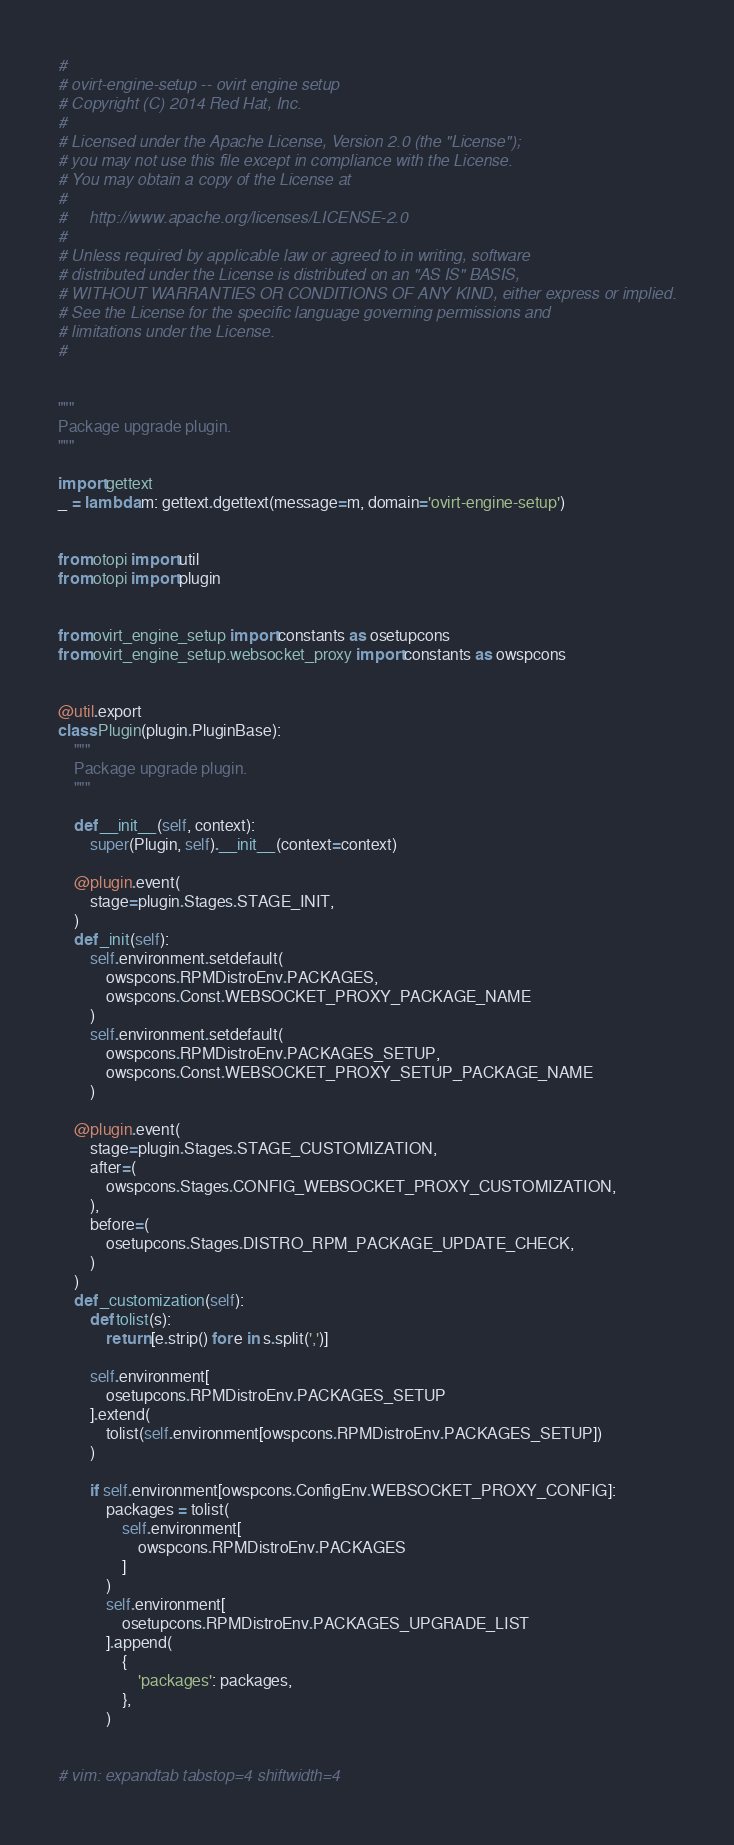Convert code to text. <code><loc_0><loc_0><loc_500><loc_500><_Python_>#
# ovirt-engine-setup -- ovirt engine setup
# Copyright (C) 2014 Red Hat, Inc.
#
# Licensed under the Apache License, Version 2.0 (the "License");
# you may not use this file except in compliance with the License.
# You may obtain a copy of the License at
#
#     http://www.apache.org/licenses/LICENSE-2.0
#
# Unless required by applicable law or agreed to in writing, software
# distributed under the License is distributed on an "AS IS" BASIS,
# WITHOUT WARRANTIES OR CONDITIONS OF ANY KIND, either express or implied.
# See the License for the specific language governing permissions and
# limitations under the License.
#


"""
Package upgrade plugin.
"""

import gettext
_ = lambda m: gettext.dgettext(message=m, domain='ovirt-engine-setup')


from otopi import util
from otopi import plugin


from ovirt_engine_setup import constants as osetupcons
from ovirt_engine_setup.websocket_proxy import constants as owspcons


@util.export
class Plugin(plugin.PluginBase):
    """
    Package upgrade plugin.
    """

    def __init__(self, context):
        super(Plugin, self).__init__(context=context)

    @plugin.event(
        stage=plugin.Stages.STAGE_INIT,
    )
    def _init(self):
        self.environment.setdefault(
            owspcons.RPMDistroEnv.PACKAGES,
            owspcons.Const.WEBSOCKET_PROXY_PACKAGE_NAME
        )
        self.environment.setdefault(
            owspcons.RPMDistroEnv.PACKAGES_SETUP,
            owspcons.Const.WEBSOCKET_PROXY_SETUP_PACKAGE_NAME
        )

    @plugin.event(
        stage=plugin.Stages.STAGE_CUSTOMIZATION,
        after=(
            owspcons.Stages.CONFIG_WEBSOCKET_PROXY_CUSTOMIZATION,
        ),
        before=(
            osetupcons.Stages.DISTRO_RPM_PACKAGE_UPDATE_CHECK,
        )
    )
    def _customization(self):
        def tolist(s):
            return [e.strip() for e in s.split(',')]

        self.environment[
            osetupcons.RPMDistroEnv.PACKAGES_SETUP
        ].extend(
            tolist(self.environment[owspcons.RPMDistroEnv.PACKAGES_SETUP])
        )

        if self.environment[owspcons.ConfigEnv.WEBSOCKET_PROXY_CONFIG]:
            packages = tolist(
                self.environment[
                    owspcons.RPMDistroEnv.PACKAGES
                ]
            )
            self.environment[
                osetupcons.RPMDistroEnv.PACKAGES_UPGRADE_LIST
            ].append(
                {
                    'packages': packages,
                },
            )


# vim: expandtab tabstop=4 shiftwidth=4
</code> 